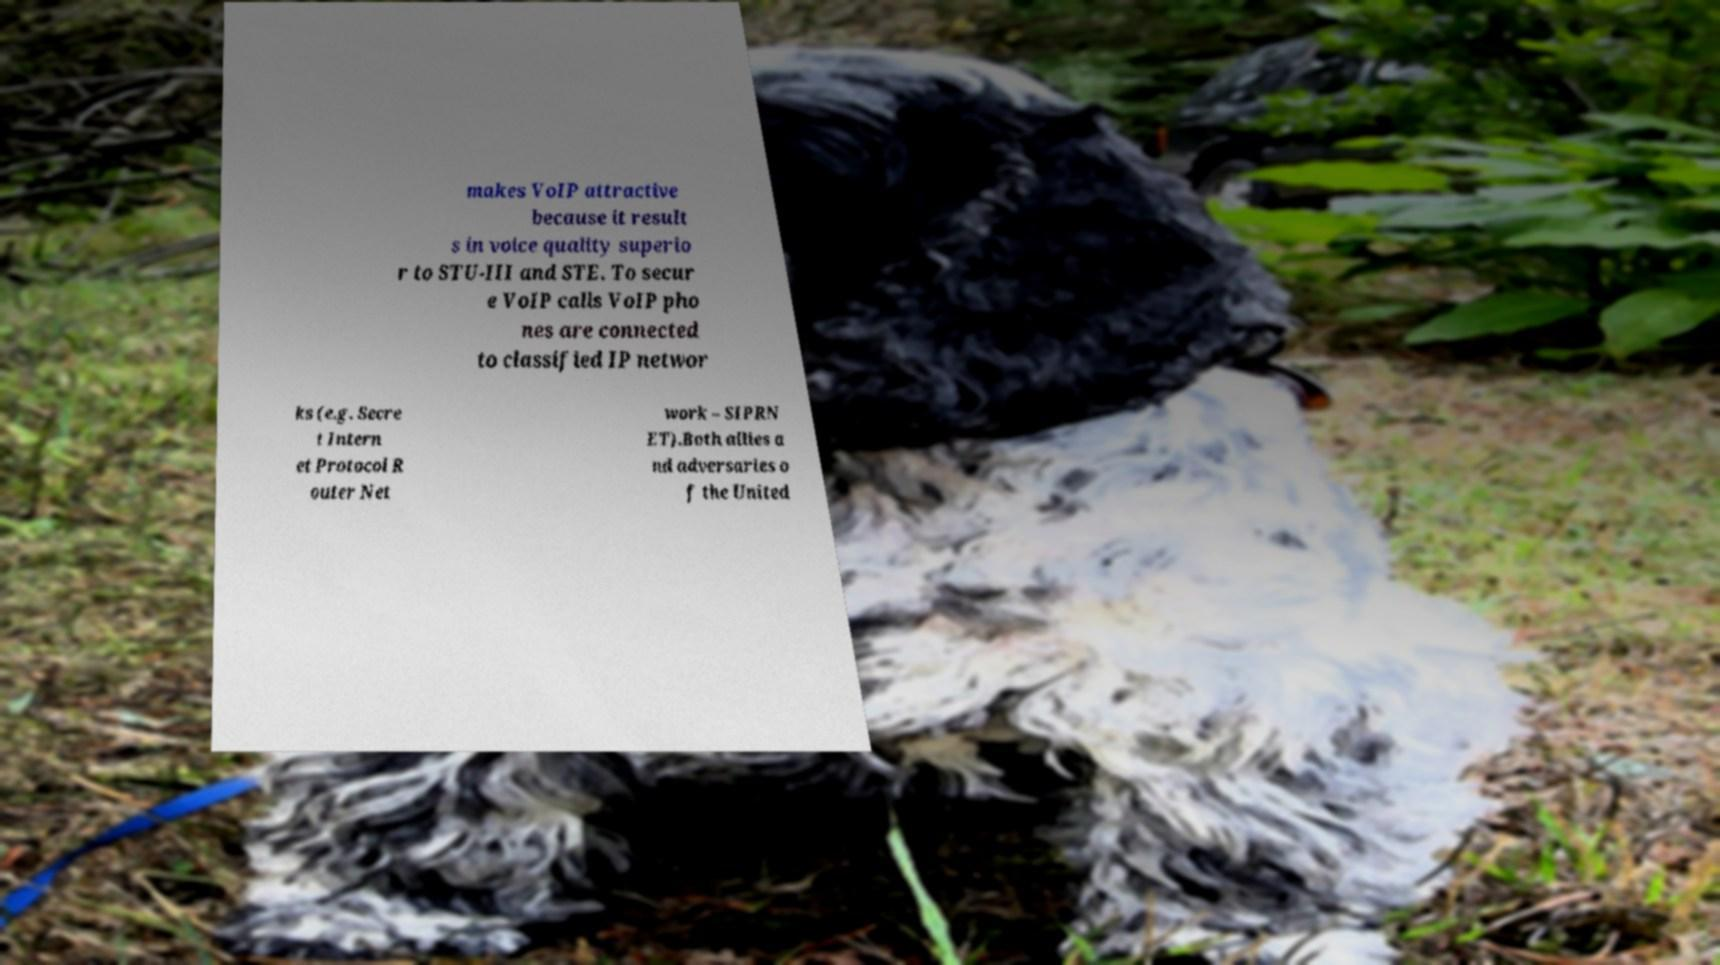Please read and relay the text visible in this image. What does it say? makes VoIP attractive because it result s in voice quality superio r to STU-III and STE. To secur e VoIP calls VoIP pho nes are connected to classified IP networ ks (e.g. Secre t Intern et Protocol R outer Net work – SIPRN ET).Both allies a nd adversaries o f the United 